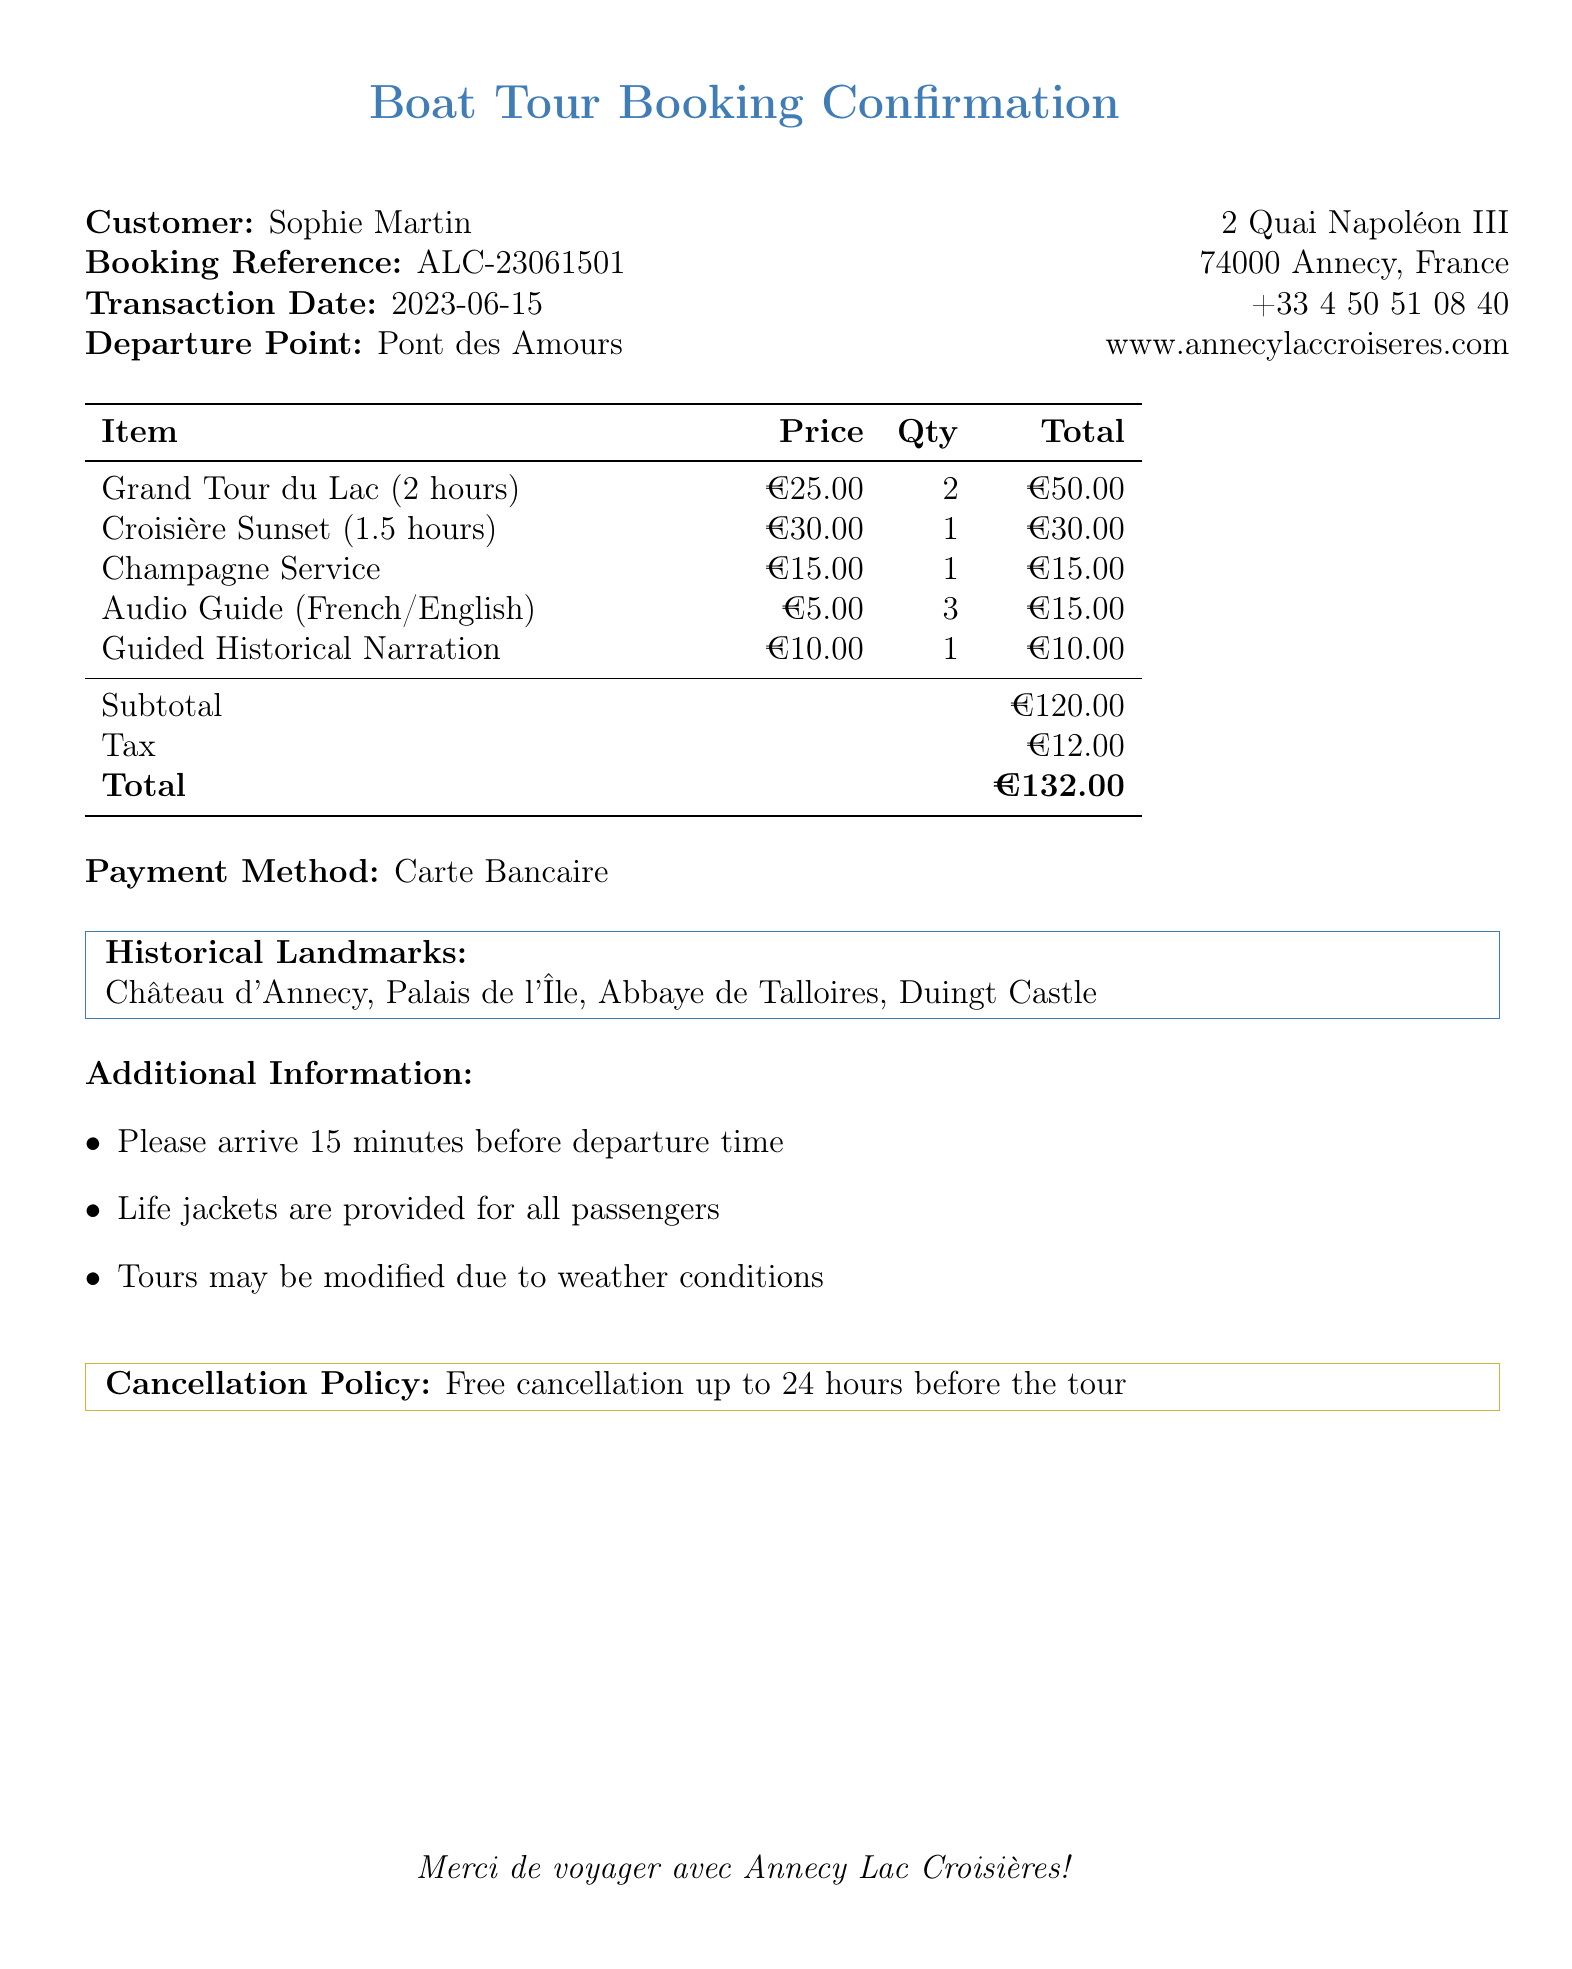What is the customer name? The document specifically mentions the name of the customer associated with this transaction.
Answer: Sophie Martin What is the total amount charged? The total amount charged is stated at the end of the billing details section of the document.
Answer: €132.00 How many Grand Tour du Lac tickets were booked? The document provides detailed information about the tour packages, including the quantity for each package.
Answer: 2 What is the price of the Champagne Service add-on? The document lists each optional add-on along with its price, including the Champagne Service.
Answer: €15.00 What is the cancellation policy? The document explicitly states the cancellation terms applicable to the booking.
Answer: Free cancellation up to 24 hours before the tour What is the booking reference number? The booking reference number is provided to uniquely identify the customer's transaction in the document.
Answer: ALC-23061501 Which two historical landmarks are mentioned in the document? The document lists several historical landmarks, and this question requires identifying any two of them.
Answer: Château d'Annecy, Palais de l'Île What is the payment method used? The document specifies how the payment was processed, detailing the method used for the transaction.
Answer: Carte Bancaire What is the duration of the Croisière Sunset tour? The document provides information about each tour package, including their respective durations.
Answer: 1.5 hours 